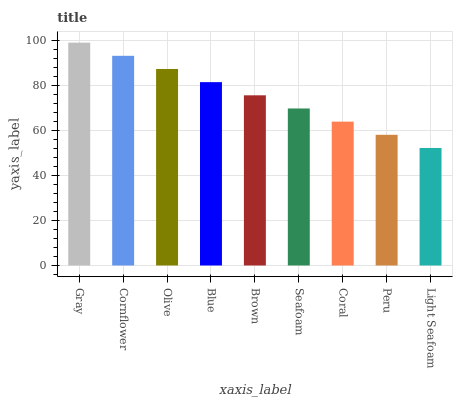Is Light Seafoam the minimum?
Answer yes or no. Yes. Is Gray the maximum?
Answer yes or no. Yes. Is Cornflower the minimum?
Answer yes or no. No. Is Cornflower the maximum?
Answer yes or no. No. Is Gray greater than Cornflower?
Answer yes or no. Yes. Is Cornflower less than Gray?
Answer yes or no. Yes. Is Cornflower greater than Gray?
Answer yes or no. No. Is Gray less than Cornflower?
Answer yes or no. No. Is Brown the high median?
Answer yes or no. Yes. Is Brown the low median?
Answer yes or no. Yes. Is Gray the high median?
Answer yes or no. No. Is Seafoam the low median?
Answer yes or no. No. 